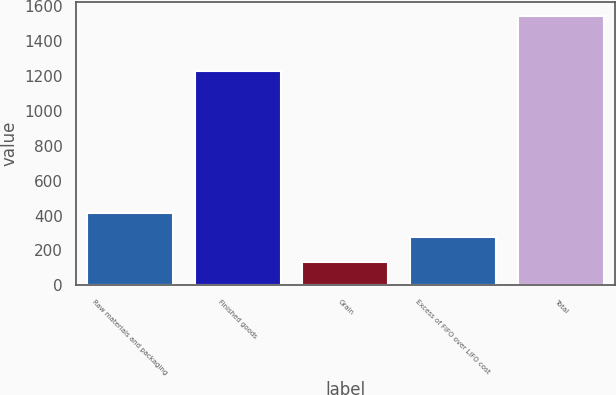Convert chart to OTSL. <chart><loc_0><loc_0><loc_500><loc_500><bar_chart><fcel>Raw materials and packaging<fcel>Finished goods<fcel>Grain<fcel>Excess of FIFO over LIFO cost<fcel>Total<nl><fcel>417.58<fcel>1228.7<fcel>135.6<fcel>276.59<fcel>1545.5<nl></chart> 